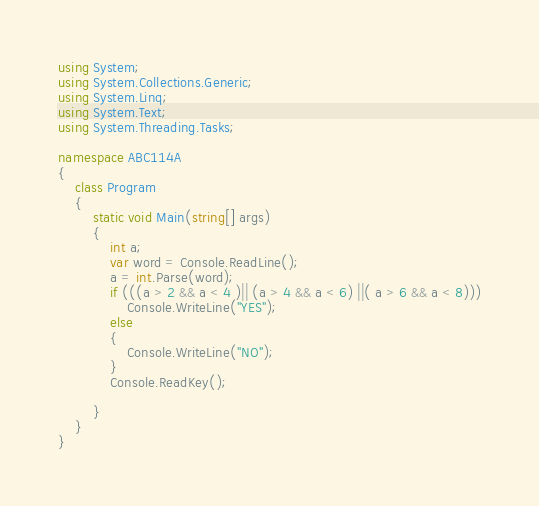<code> <loc_0><loc_0><loc_500><loc_500><_C#_>using System;
using System.Collections.Generic;
using System.Linq;
using System.Text;
using System.Threading.Tasks;

namespace ABC114A
{
    class Program
    {
        static void Main(string[] args)
        {
            int a;
            var word = Console.ReadLine();
            a = int.Parse(word);
            if (((a > 2 && a < 4 )|| (a > 4 && a < 6) ||( a > 6 && a < 8)))
                Console.WriteLine("YES");
            else
            {
                Console.WriteLine("NO");
            }
            Console.ReadKey();

        }
    }
}

</code> 